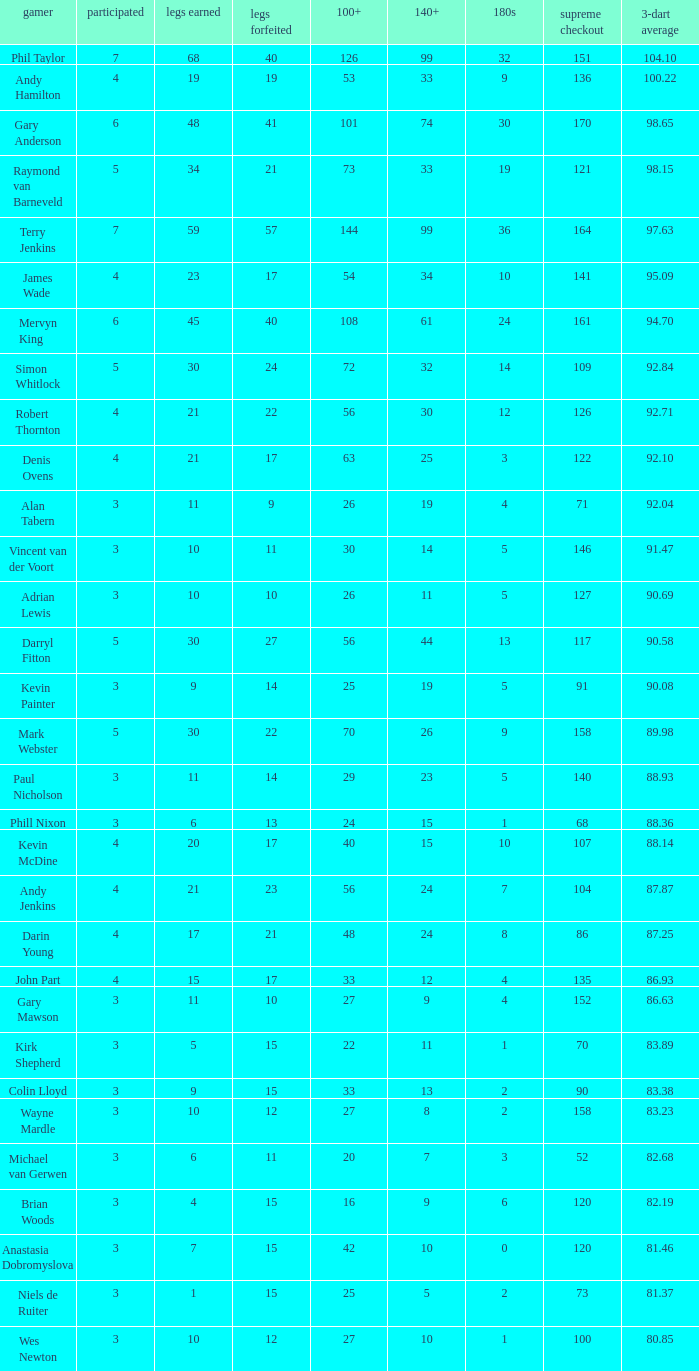What is the most legs lost of all? 57.0. 